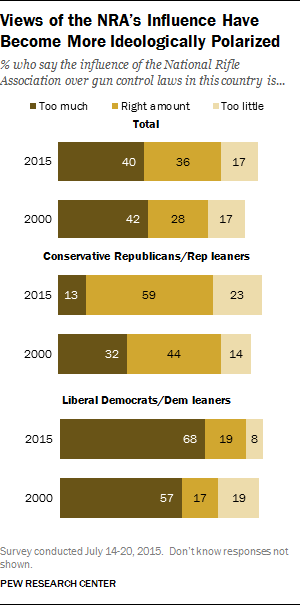Identify some key points in this picture. The two years depicted in the chart are 2000 and 2015. Liberal Democrats and Dem leaners are more likely to choose too much. 